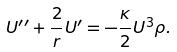Convert formula to latex. <formula><loc_0><loc_0><loc_500><loc_500>U ^ { \prime \prime } + \frac { 2 } { r } U ^ { \prime } = - \frac { \kappa } { 2 } U ^ { 3 } \rho .</formula> 